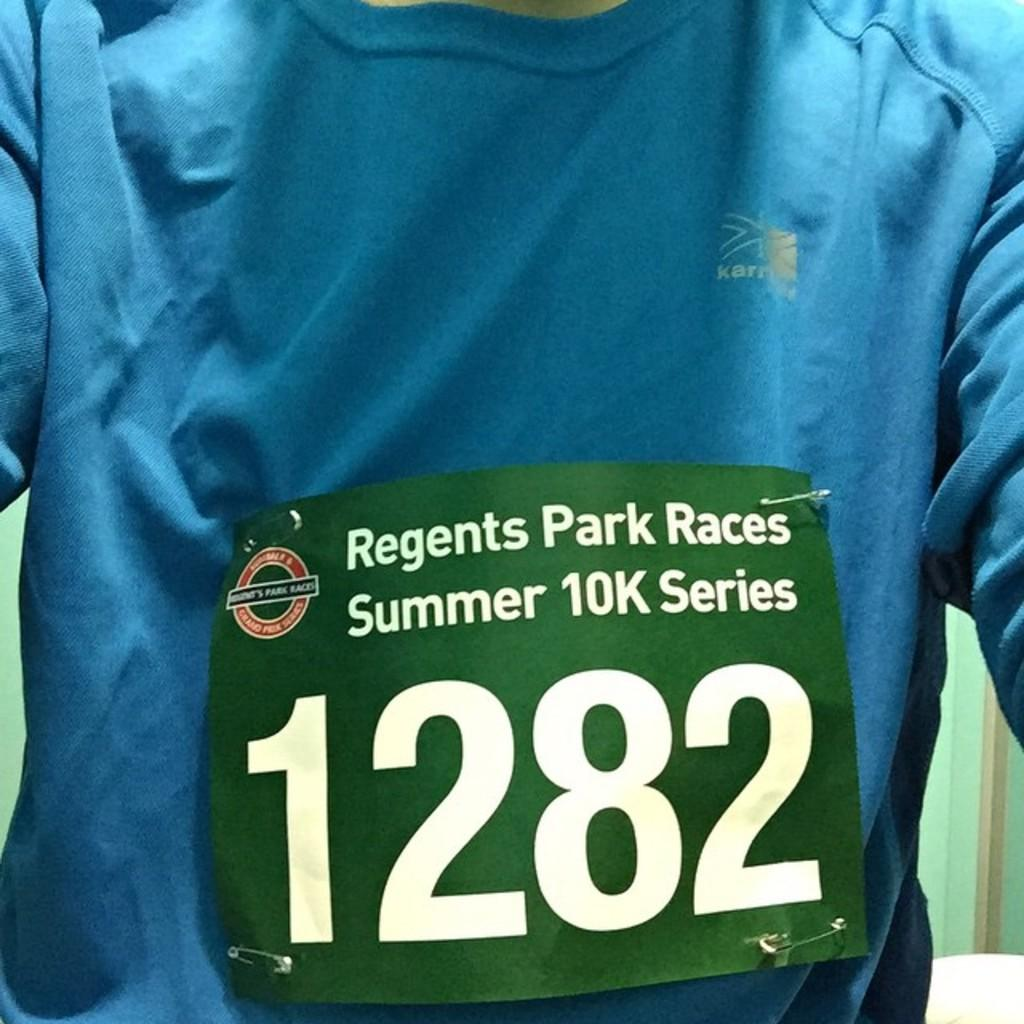Where was the image taken? The image is taken indoors. What can be seen in the background of the image? There is a wall in the background of the image. Who is the main subject in the image? There is a man in the middle of the image. What is on the wall in the image? There is a poster with text in the image. What is the man wearing in the image? The man is wearing a T-shirt with text on it. How many mint leaves are on the man's leg in the image? There are no mint leaves or legs visible in the image; it features a man wearing a T-shirt with text in an indoor setting with a wall and a poster in the background. 